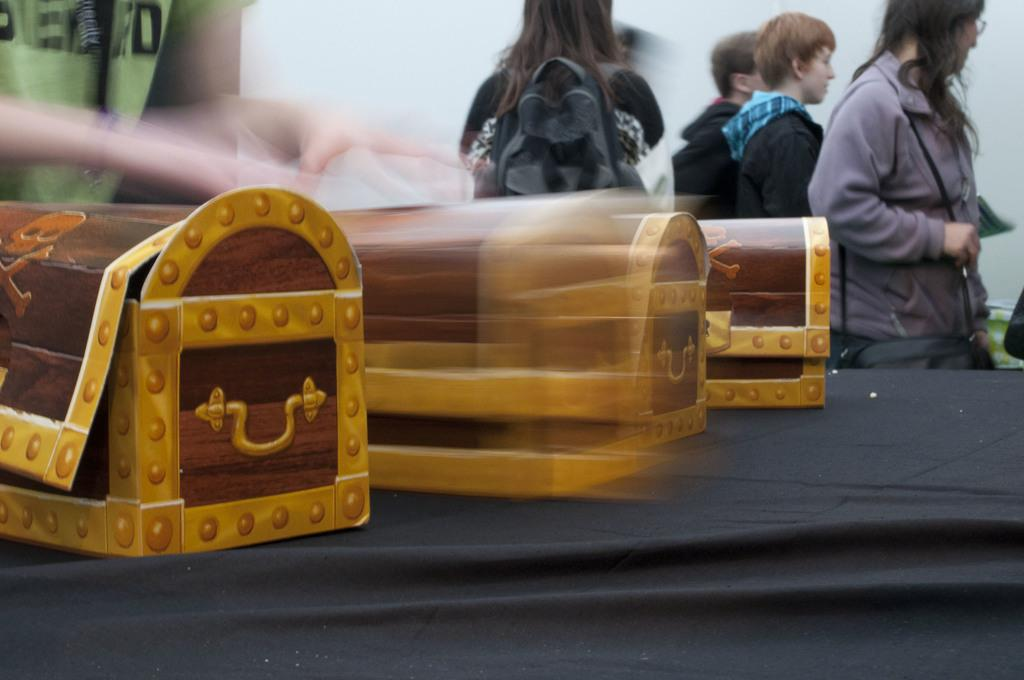What is the main piece of furniture in the image? There is a table in the image. What objects are placed on the table? There are three wooden boxes on the table. Can you describe the people in the image? There are people behind the table. What can be seen in the background of the image? There is a wall in the background of the image. What type of collar can be seen on the wall in the image? There is no collar present on the wall in the image. 